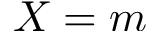<formula> <loc_0><loc_0><loc_500><loc_500>X = m</formula> 